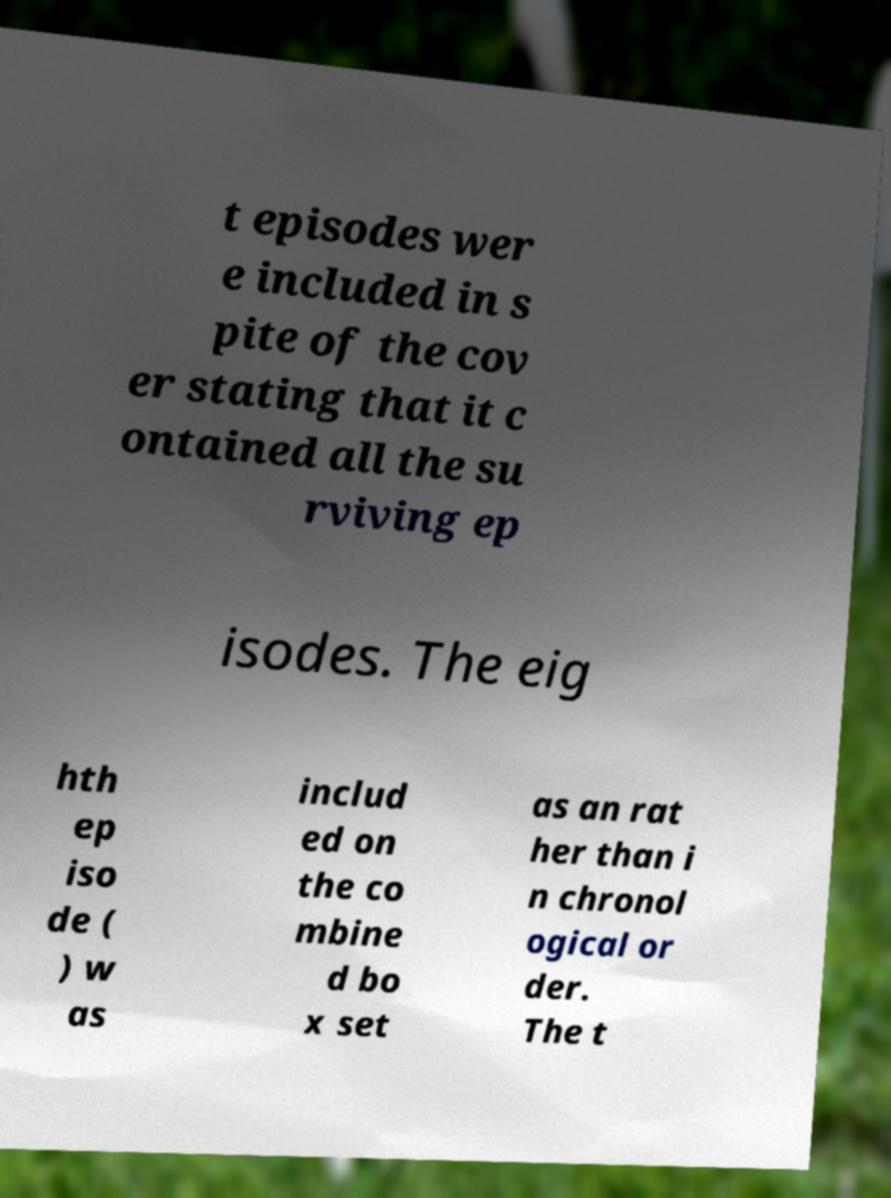For documentation purposes, I need the text within this image transcribed. Could you provide that? t episodes wer e included in s pite of the cov er stating that it c ontained all the su rviving ep isodes. The eig hth ep iso de ( ) w as includ ed on the co mbine d bo x set as an rat her than i n chronol ogical or der. The t 